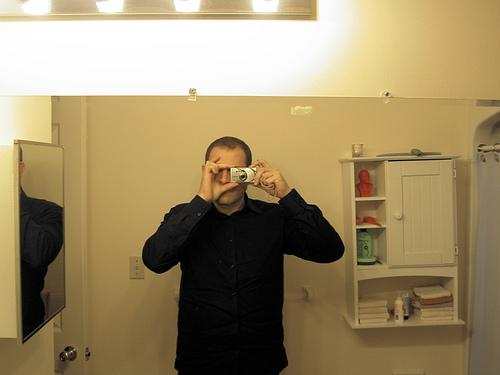What type of camera is he using? digital 